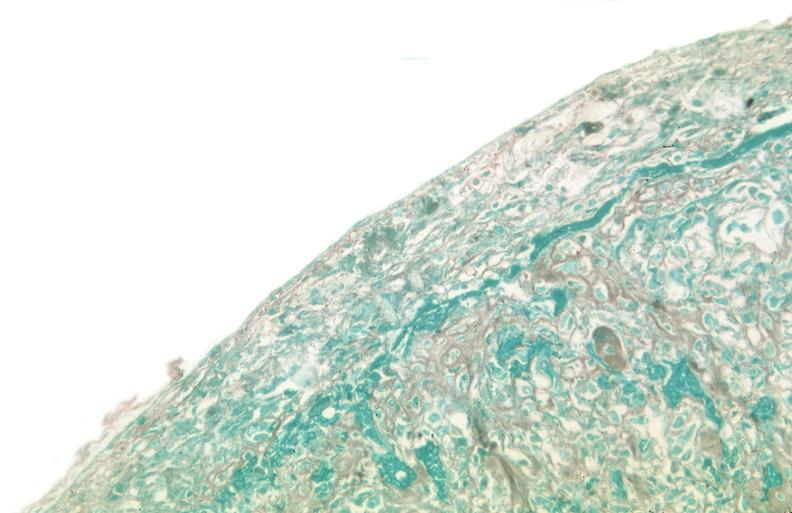what is present?
Answer the question using a single word or phrase. Respiratory 